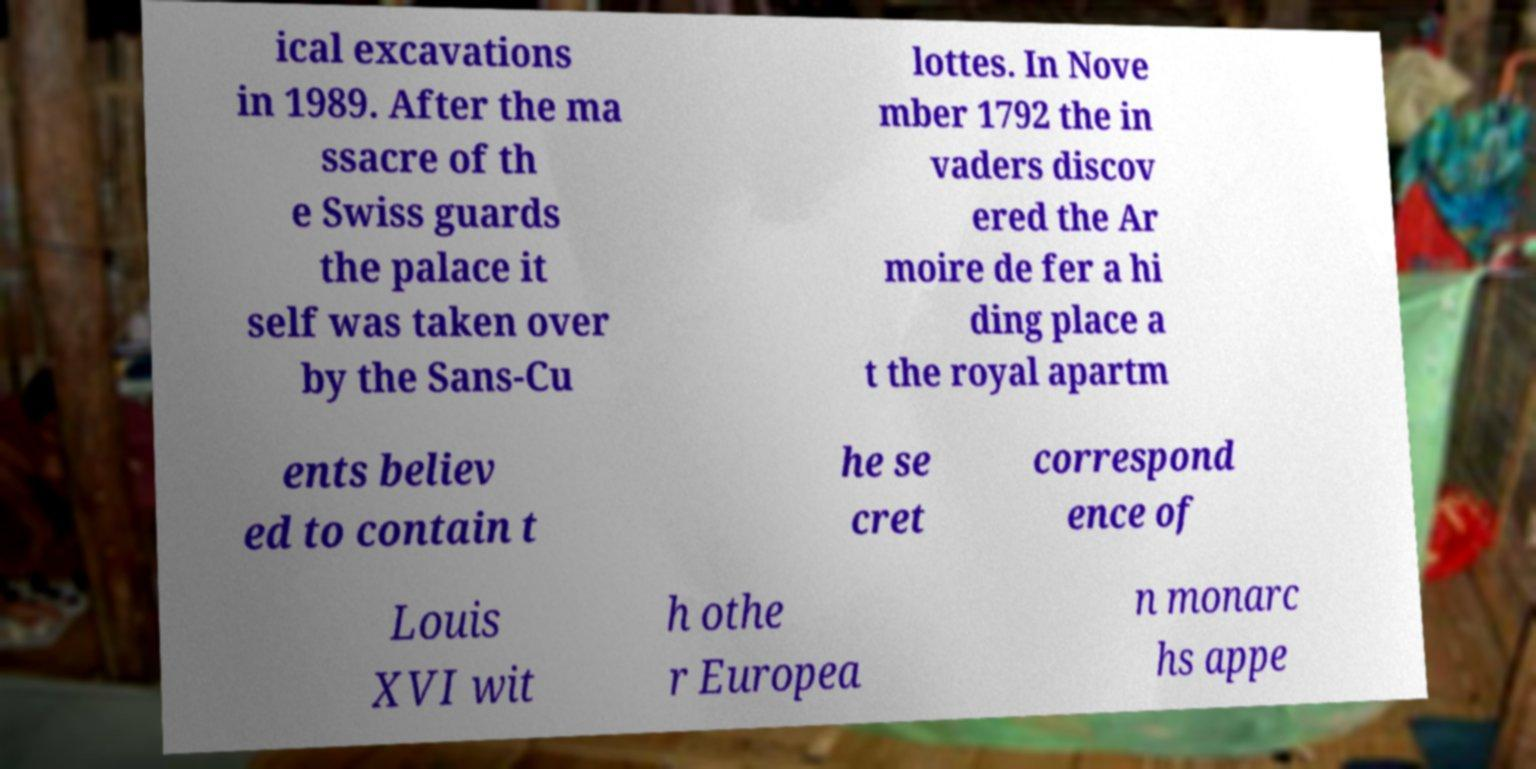For documentation purposes, I need the text within this image transcribed. Could you provide that? ical excavations in 1989. After the ma ssacre of th e Swiss guards the palace it self was taken over by the Sans-Cu lottes. In Nove mber 1792 the in vaders discov ered the Ar moire de fer a hi ding place a t the royal apartm ents believ ed to contain t he se cret correspond ence of Louis XVI wit h othe r Europea n monarc hs appe 